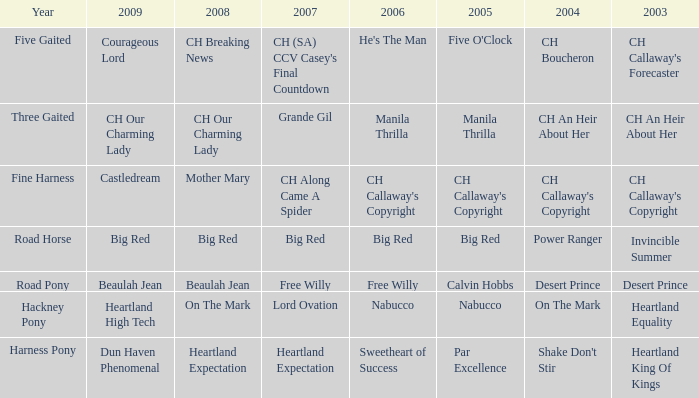What is the 2007 for the 2003 desert prince? Free Willy. 